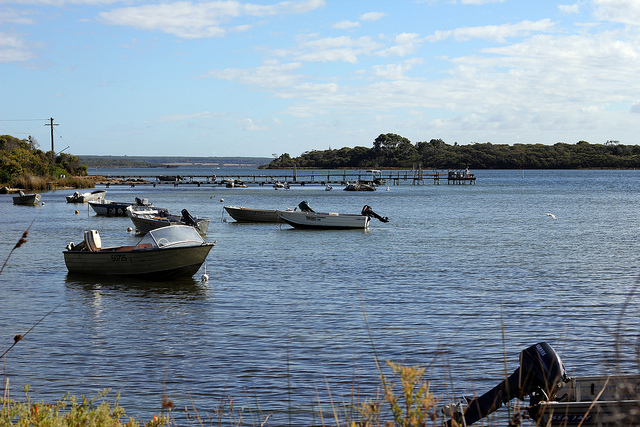Envision a perfect day spent here. Imagine starting your day at dawn, with the sky painted in hues of pink and orange as the sun gently rises, casting a warm glow across the lake. You could take a boat out into the calm waters, enjoying the quiet, peaceful ambiance as you fish or simply relax, absorbing the serenity of your surroundings. As the day progresses, you could explore the nearby shoreline, perhaps finding a secluded spot to read or have a picnic. The soft rustling of leaves and the occasional call of birds would be the only sounds, further enhancing your feeling of escape from the hustle and bustle of daily life. As evening falls, you would return to the dock, watching as the sky transforms into a tapestry of stars, reflecting beautifully on the lake surface, rounding out a perfect, tranquil day spent in harmony with nature. 